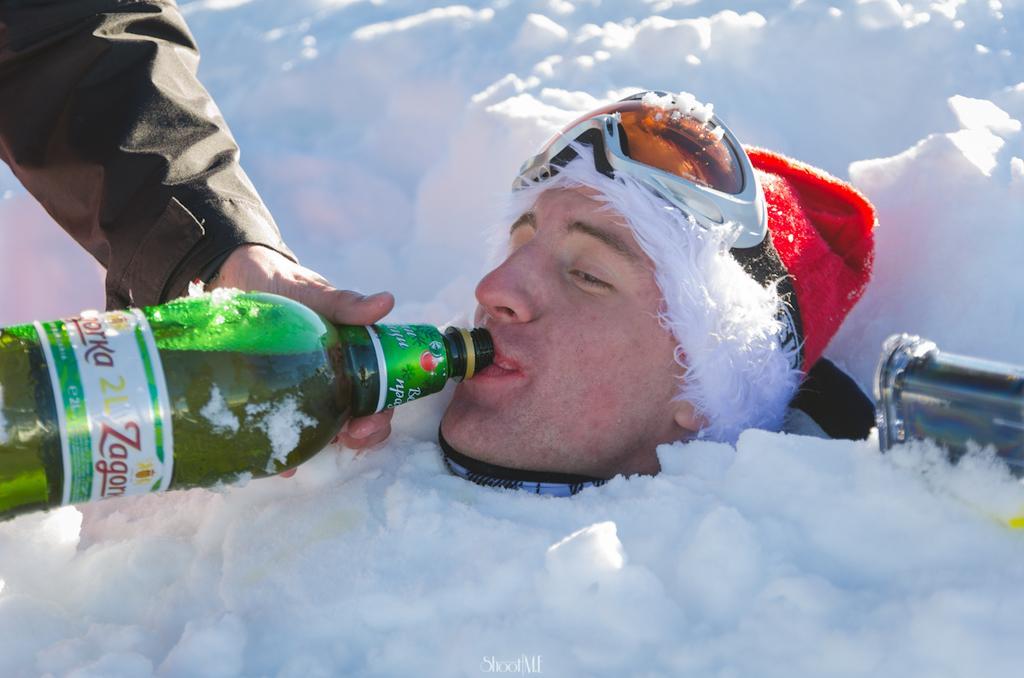How would you summarize this image in a sentence or two? The person whose body is dipped in the snow and only his face is visible is drinking. 